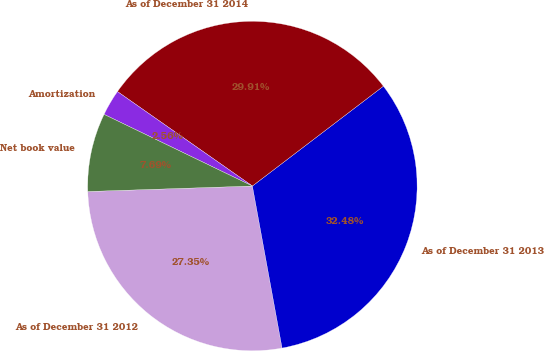<chart> <loc_0><loc_0><loc_500><loc_500><pie_chart><fcel>As of December 31 2012<fcel>As of December 31 2013<fcel>As of December 31 2014<fcel>Amortization<fcel>Net book value<nl><fcel>27.35%<fcel>32.48%<fcel>29.91%<fcel>2.56%<fcel>7.69%<nl></chart> 